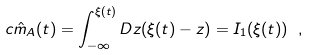Convert formula to latex. <formula><loc_0><loc_0><loc_500><loc_500>c \hat { m } _ { A } ( t ) = \int _ { - \infty } ^ { \xi ( t ) } D z ( \xi ( t ) - z ) = I _ { 1 } ( \xi ( t ) ) \ ,</formula> 